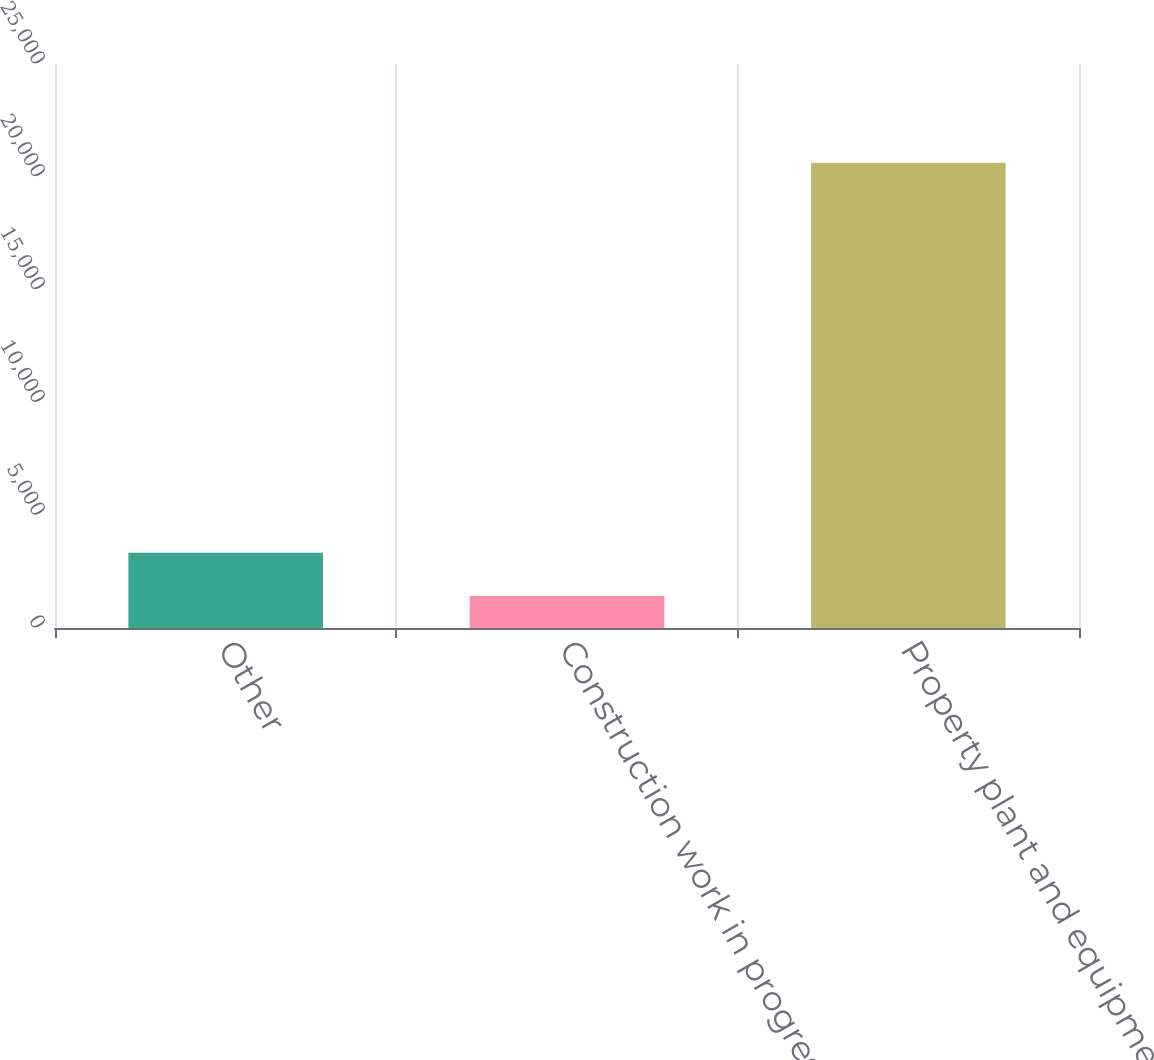<chart> <loc_0><loc_0><loc_500><loc_500><bar_chart><fcel>Other<fcel>Construction work in progress<fcel>Property plant and equipment -<nl><fcel>3340.4<fcel>1420<fcel>20624<nl></chart> 